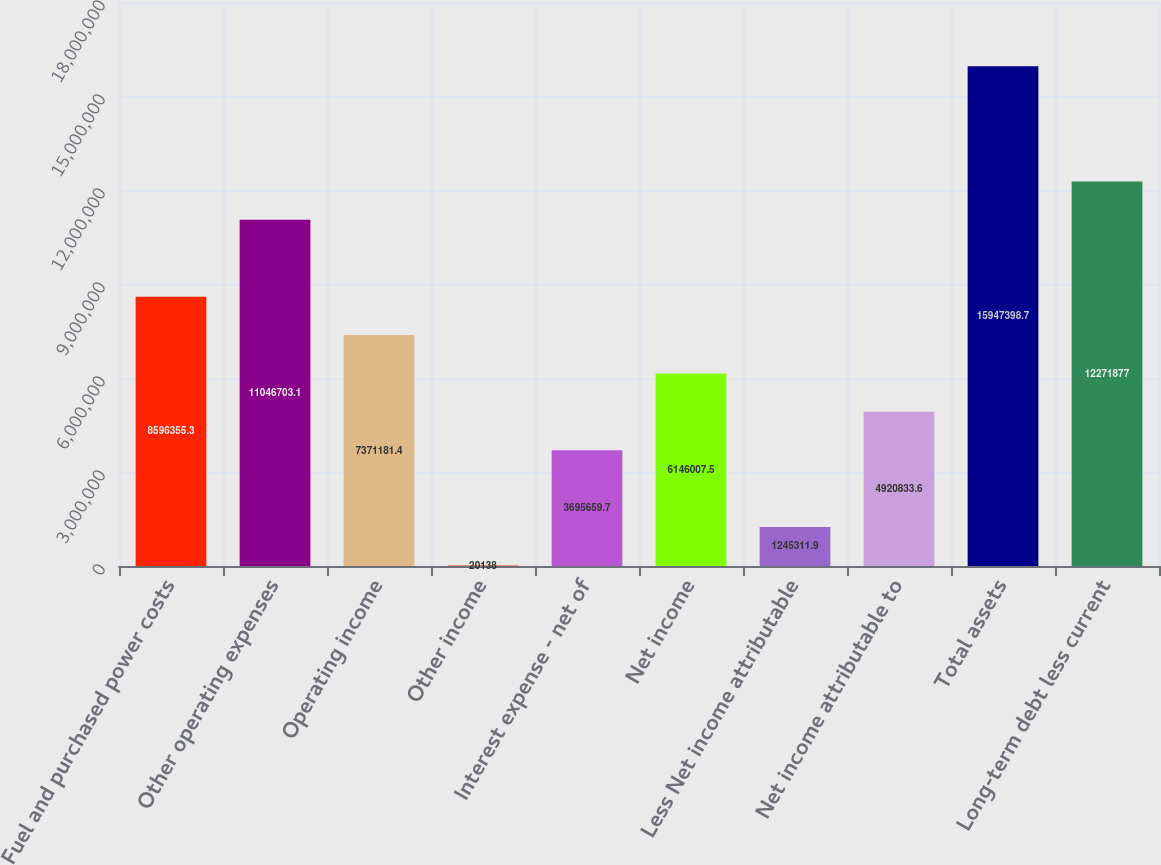Convert chart to OTSL. <chart><loc_0><loc_0><loc_500><loc_500><bar_chart><fcel>Fuel and purchased power costs<fcel>Other operating expenses<fcel>Operating income<fcel>Other income<fcel>Interest expense - net of<fcel>Net income<fcel>Less Net income attributable<fcel>Net income attributable to<fcel>Total assets<fcel>Long-term debt less current<nl><fcel>8.59636e+06<fcel>1.10467e+07<fcel>7.37118e+06<fcel>20138<fcel>3.69566e+06<fcel>6.14601e+06<fcel>1.24531e+06<fcel>4.92083e+06<fcel>1.59474e+07<fcel>1.22719e+07<nl></chart> 